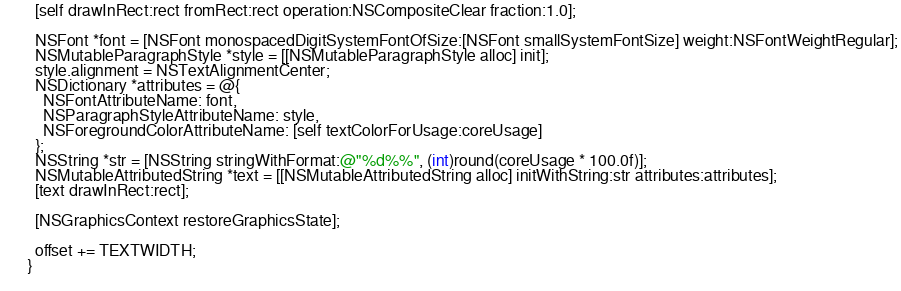<code> <loc_0><loc_0><loc_500><loc_500><_ObjectiveC_>        [self drawInRect:rect fromRect:rect operation:NSCompositeClear fraction:1.0];
        
        NSFont *font = [NSFont monospacedDigitSystemFontOfSize:[NSFont smallSystemFontSize] weight:NSFontWeightRegular];
        NSMutableParagraphStyle *style = [[NSMutableParagraphStyle alloc] init];
        style.alignment = NSTextAlignmentCenter;
        NSDictionary *attributes = @{
          NSFontAttributeName: font,
          NSParagraphStyleAttributeName: style,
          NSForegroundColorAttributeName: [self textColorForUsage:coreUsage]
        };
        NSString *str = [NSString stringWithFormat:@"%d%%", (int)round(coreUsage * 100.0f)];
        NSMutableAttributedString *text = [[NSMutableAttributedString alloc] initWithString:str attributes:attributes];
        [text drawInRect:rect];
        
        [NSGraphicsContext restoreGraphicsState];
        
        offset += TEXTWIDTH;
      }
      </code> 